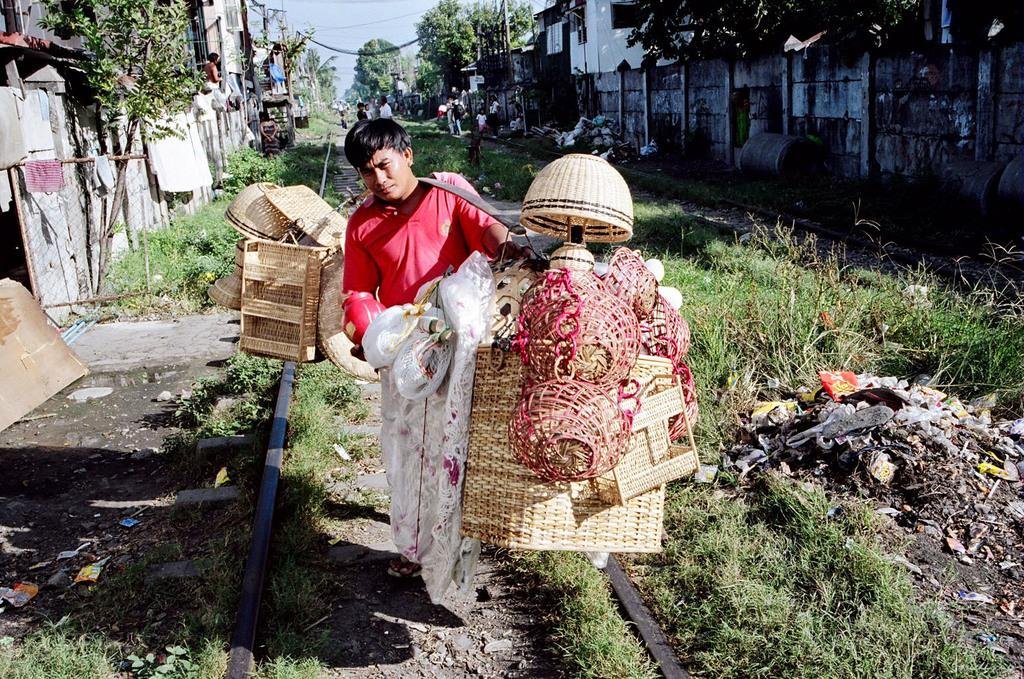What is the person in the image doing? The person is standing on the ground in the image. What else can be seen in the image besides the person? There are objects, train tracks, grass, plants, houses, walls, trees, and the sky visible in the image. Can you describe the setting of the image? The image shows a person standing near train tracks, surrounded by grass, plants, and trees in the background. There are houses and walls visible in the distance, and the sky is also visible. Where is the scarecrow located in the image? There is no scarecrow present in the image. What type of nail is being used to hold the cushion in place in the image? There is no cushion or nail present in the image. 